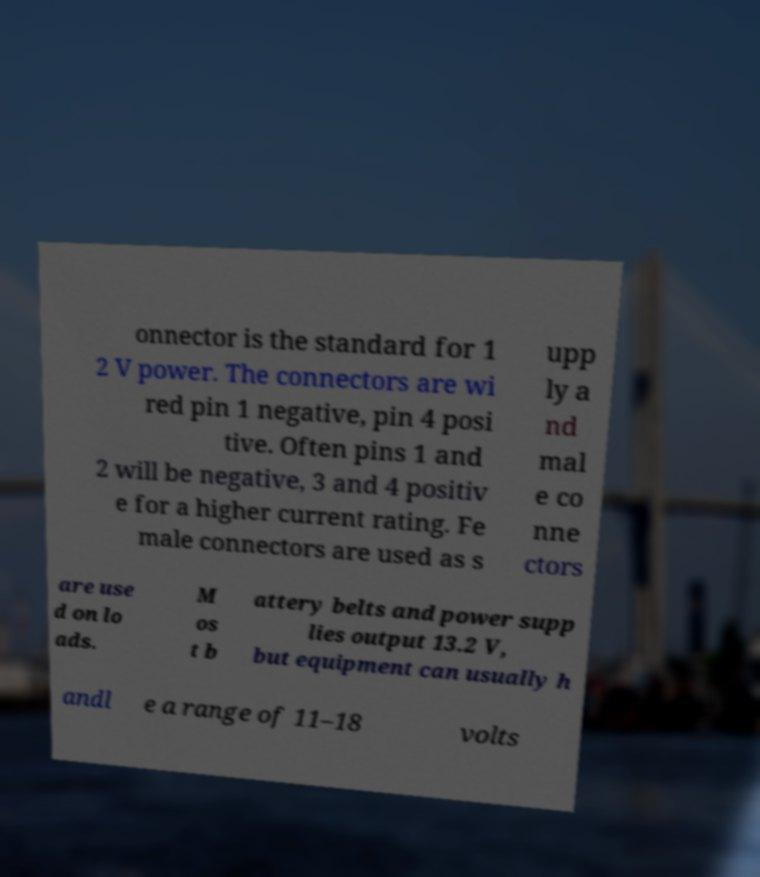Can you accurately transcribe the text from the provided image for me? onnector is the standard for 1 2 V power. The connectors are wi red pin 1 negative, pin 4 posi tive. Often pins 1 and 2 will be negative, 3 and 4 positiv e for a higher current rating. Fe male connectors are used as s upp ly a nd mal e co nne ctors are use d on lo ads. M os t b attery belts and power supp lies output 13.2 V, but equipment can usually h andl e a range of 11–18 volts 